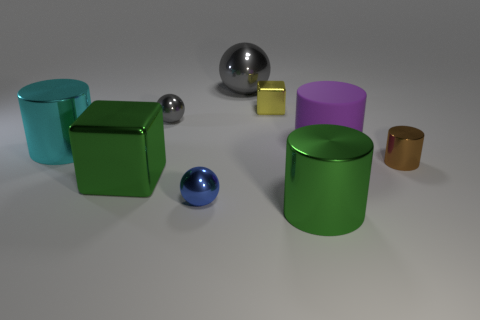Subtract all gray spheres. How many were subtracted if there are1gray spheres left? 1 Subtract all large cyan cylinders. How many cylinders are left? 3 Add 1 large cyan metal cylinders. How many objects exist? 10 Subtract all green cylinders. How many cylinders are left? 3 Subtract all green cubes. How many gray spheres are left? 2 Subtract 1 spheres. How many spheres are left? 2 Subtract all cylinders. How many objects are left? 5 Subtract 1 purple cylinders. How many objects are left? 8 Subtract all blue cubes. Subtract all yellow cylinders. How many cubes are left? 2 Subtract all metallic things. Subtract all large green blocks. How many objects are left? 0 